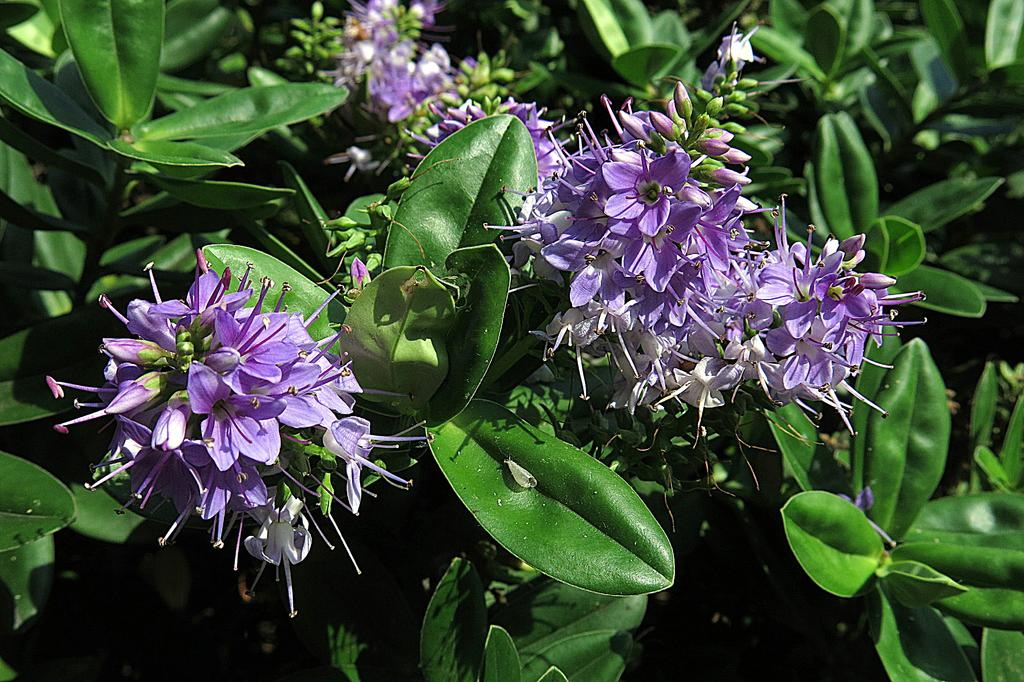What type of living organisms can be seen in the image? There are flowers in the image. Where are the flowers located? The flowers are on plants. What color are the leaves in the image? The leaves in the image are green. Can you see any snails crawling on the flowers in the image? There are no snails visible in the image; it only features flowers on plants with green leaves. 